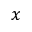Convert formula to latex. <formula><loc_0><loc_0><loc_500><loc_500>x</formula> 